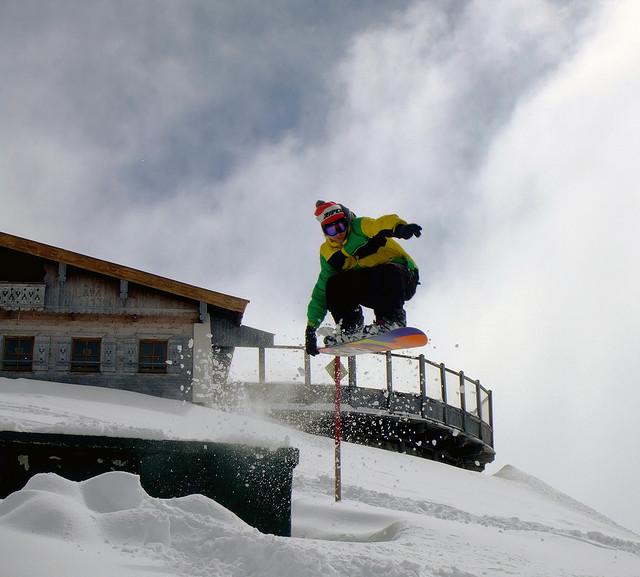What color jacket is the snowboarder wearing?
Concise answer only. Yellow, green. Is it hot outside?
Short answer required. No. What is the person standing on?
Be succinct. Snowboard. 